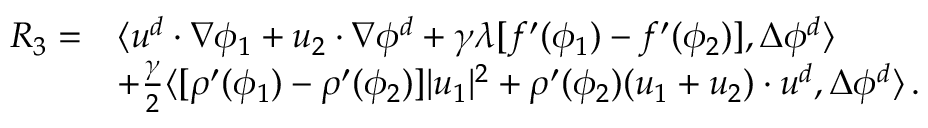<formula> <loc_0><loc_0><loc_500><loc_500>\begin{array} { r l } { R _ { 3 } = } & { \langle u ^ { d } \cdot \nabla \phi _ { 1 } + u _ { 2 } \cdot \nabla \phi ^ { d } + \gamma \lambda [ f ^ { \prime } ( \phi _ { 1 } ) - f ^ { \prime } ( \phi _ { 2 } ) ] , \Delta \phi ^ { d } \rangle } \\ & { + \frac { \gamma } { 2 } \langle [ \rho ^ { \prime } ( \phi _ { 1 } ) - \rho ^ { \prime } ( \phi _ { 2 } ) ] | u _ { 1 } | ^ { 2 } + \rho ^ { \prime } ( \phi _ { 2 } ) ( u _ { 1 } + u _ { 2 } ) \cdot u ^ { d } , \Delta \phi ^ { d } \rangle \, . } \end{array}</formula> 